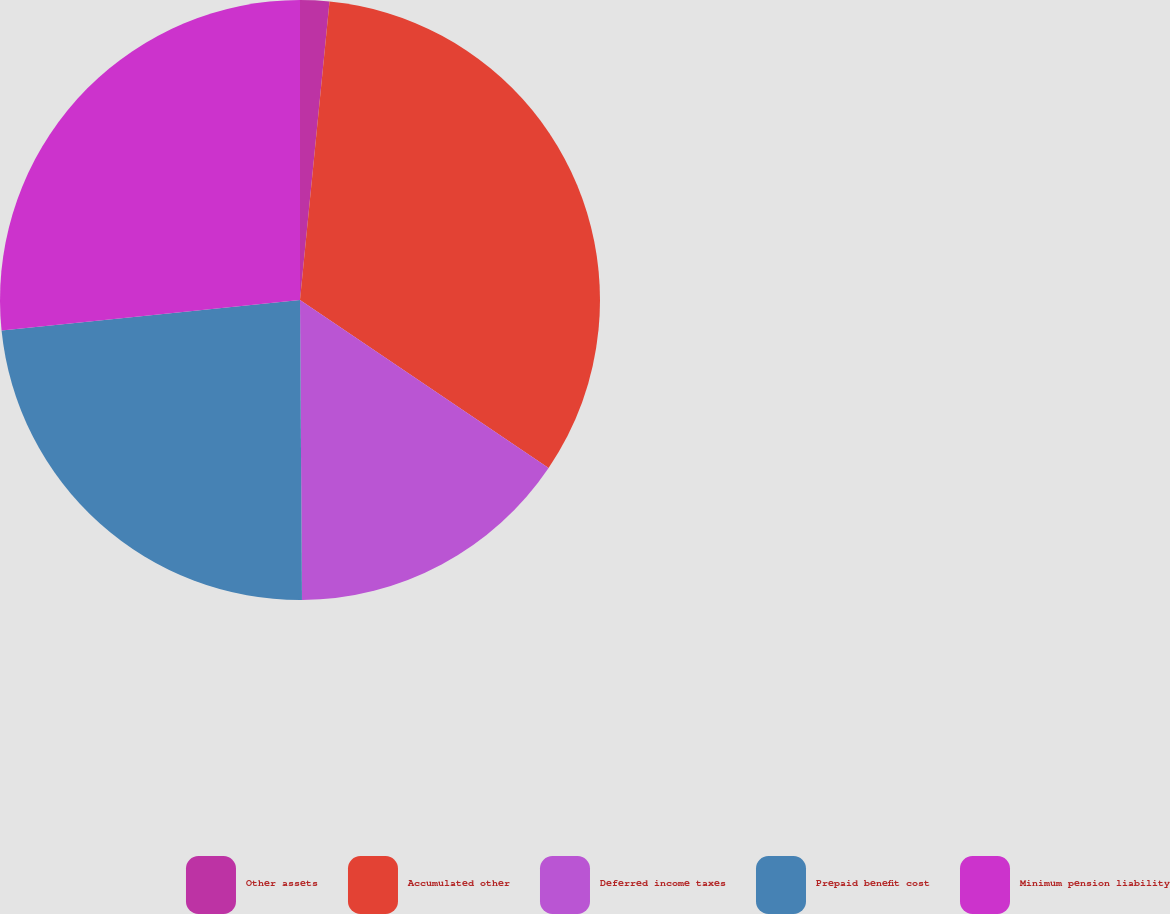Convert chart. <chart><loc_0><loc_0><loc_500><loc_500><pie_chart><fcel>Other assets<fcel>Accumulated other<fcel>Deferred income taxes<fcel>Prepaid benefit cost<fcel>Minimum pension liability<nl><fcel>1.57%<fcel>32.89%<fcel>15.44%<fcel>23.49%<fcel>26.62%<nl></chart> 